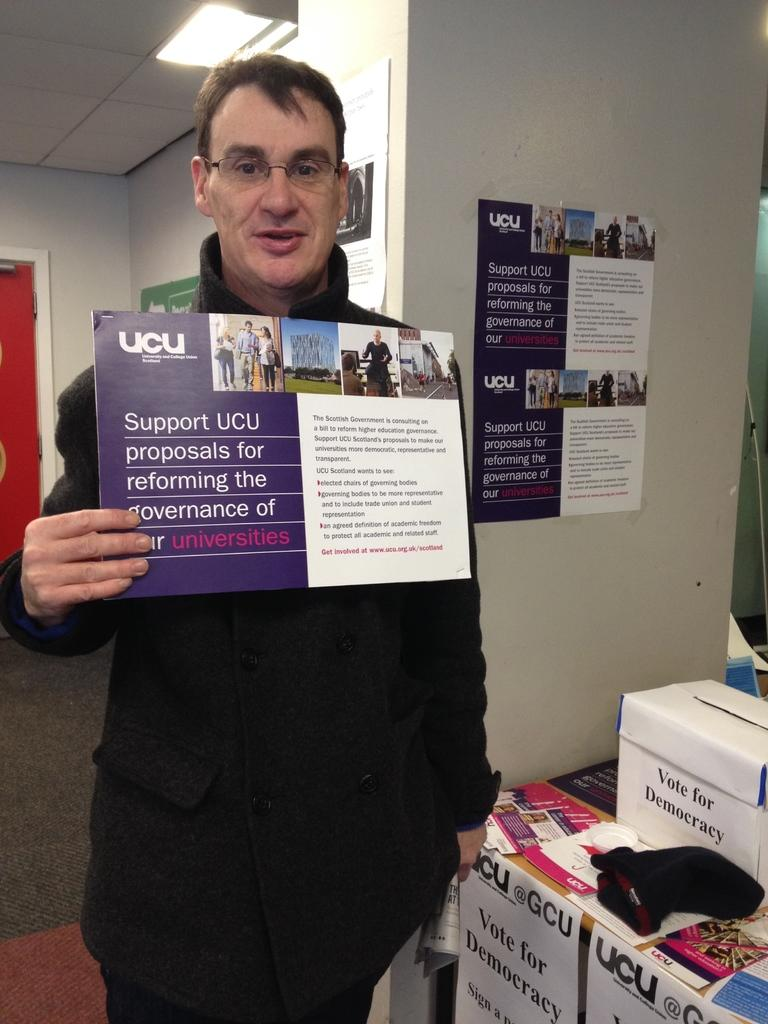<image>
Render a clear and concise summary of the photo. A man holds stands in an office, holding a sign that supports government reform. 